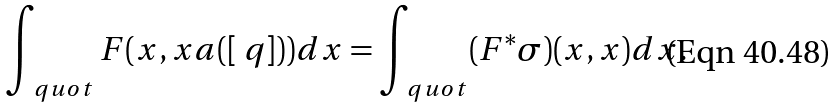Convert formula to latex. <formula><loc_0><loc_0><loc_500><loc_500>\int _ { \ q u o t } F ( x , x a ( [ \ q ] ) ) d x = \int _ { \ q u o t } ( F ^ { * } \sigma ) ( x , x ) d x .</formula> 